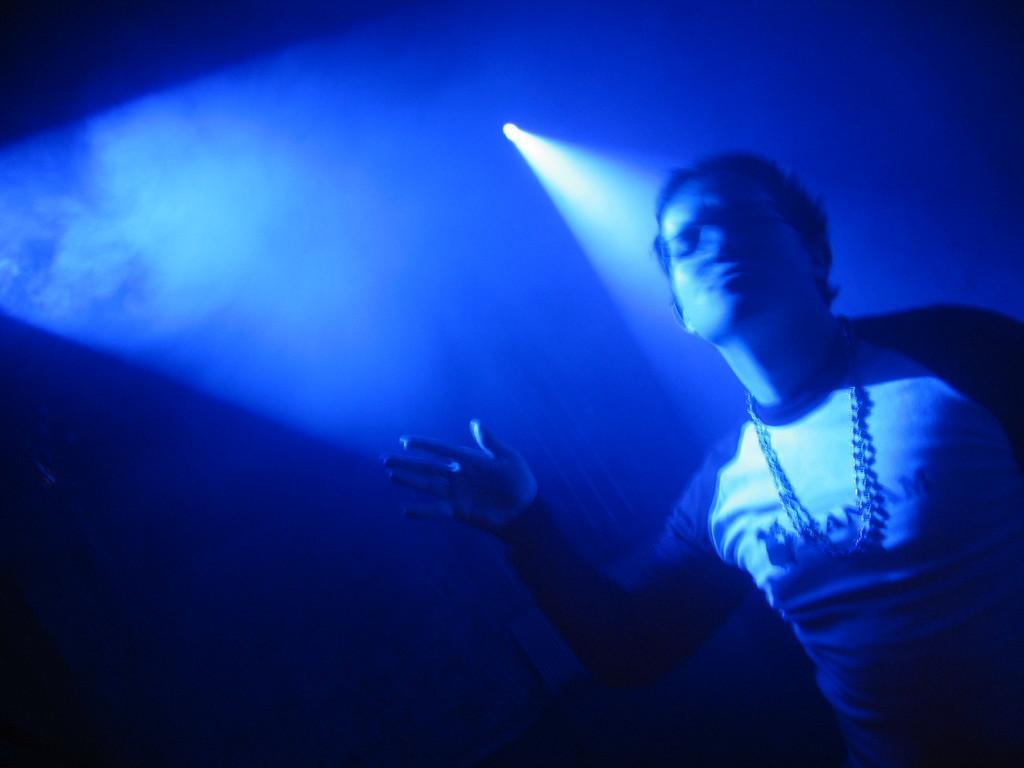Describe this image in one or two sentences. In this picture there is a person. In the background of the image it is dark and we can see light and smoke. 